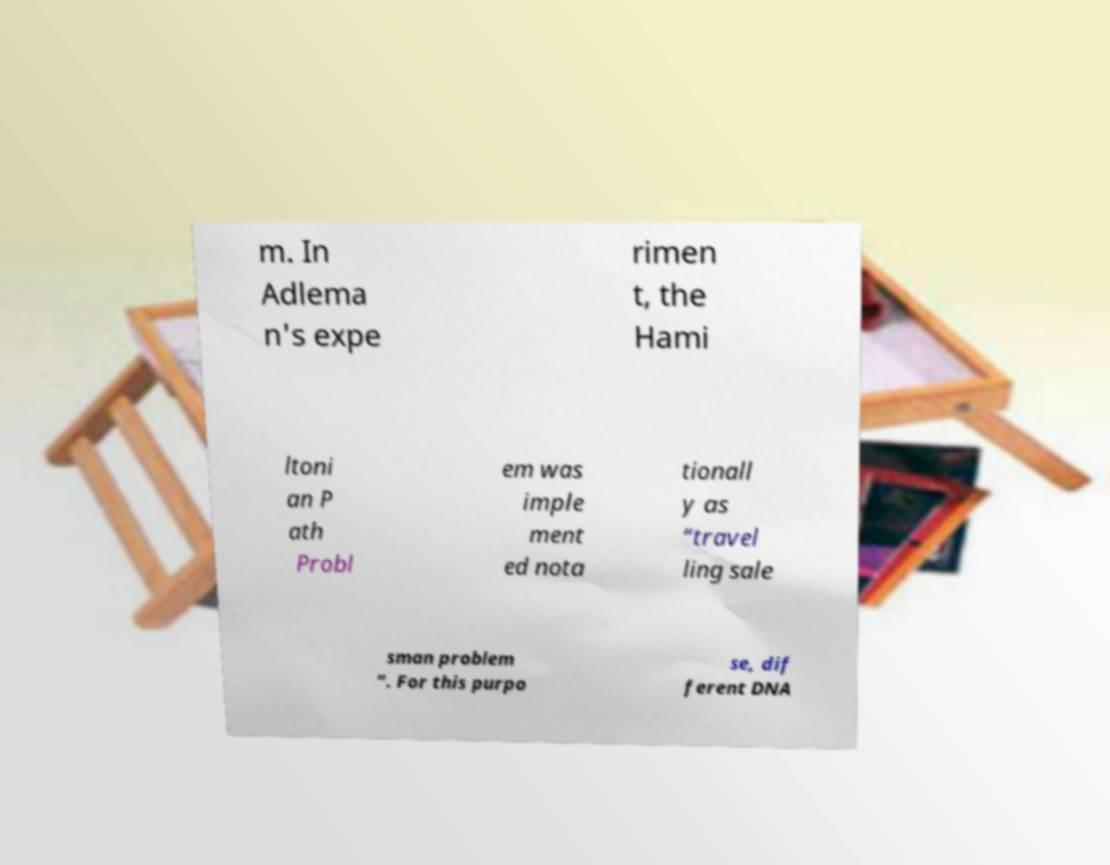Please identify and transcribe the text found in this image. m. In Adlema n's expe rimen t, the Hami ltoni an P ath Probl em was imple ment ed nota tionall y as “travel ling sale sman problem ”. For this purpo se, dif ferent DNA 